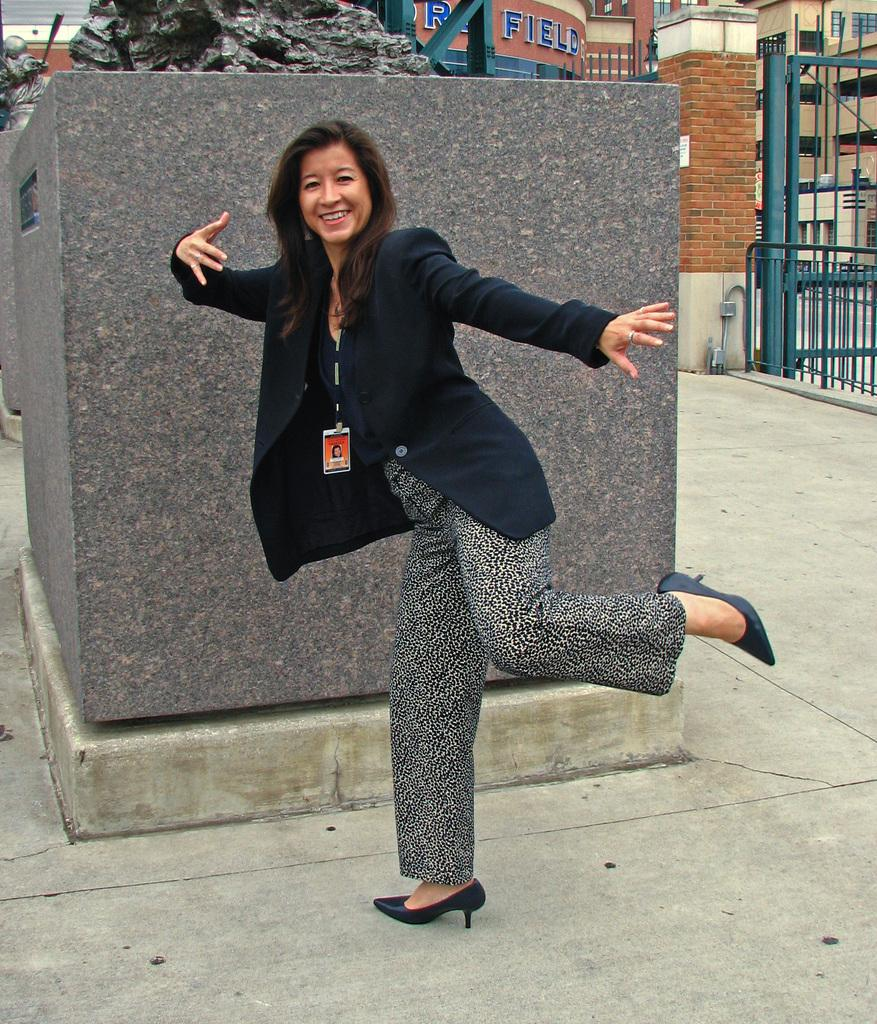Who is the main subject in the image? There is a woman standing in the center of the image. What is the woman standing on? The woman is standing on the floor. What can be seen in the background of the image? There is a statue, buildings, and a gate in the background of the image. What type of secretary is present in the image? There is no secretary present in the image; it features a woman standing in the center and various elements in the background. 